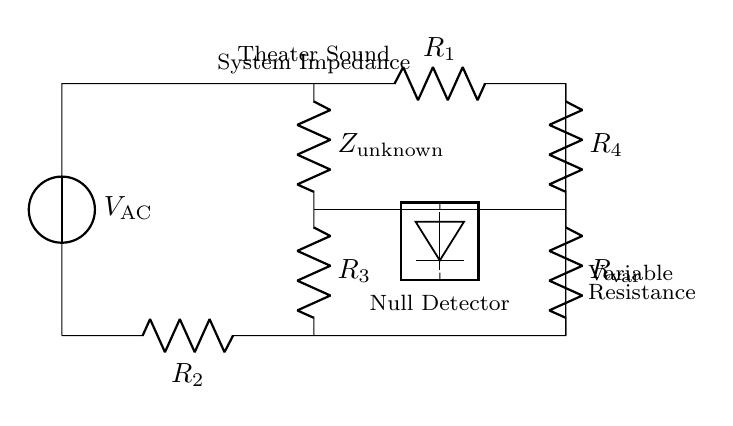What is the type of voltage source in this circuit? The voltage source is labeled as V_AC, indicating it is an alternating current source used for measuring impedance in the circuit.
Answer: Alternating current What does Z_unknown represent? Z_unknown refers to the impedance of the theater sound system, which is the component whose value we are trying to measure using the bridge circuit.
Answer: Impedance How many resistors are present in the circuit? The circuit contains a total of four resistors: R_1, R_2, R_3, and R_4.
Answer: Four What is the purpose of the null detector in this circuit? The null detector is used to find the point of balance in the bridge, where the voltages across it are equal, indicating that Z_unknown is equal to the calibrated resistances.
Answer: Balance detection What is the function of the variable resistor labeled R_var? R_var allows for adjustment in the circuit, providing a means to balance the bridge by compensating for changes in Z_unknown until a null reading is achieved.
Answer: Adjustment What are the two primary measurements being compared in this bridge circuit? The bridge circuit compares the known resistances (R_1, R_2, R_3, and R_4) with the unknown impedance (Z_unknown) to determine its value.
Answer: Known and unknown impedance 